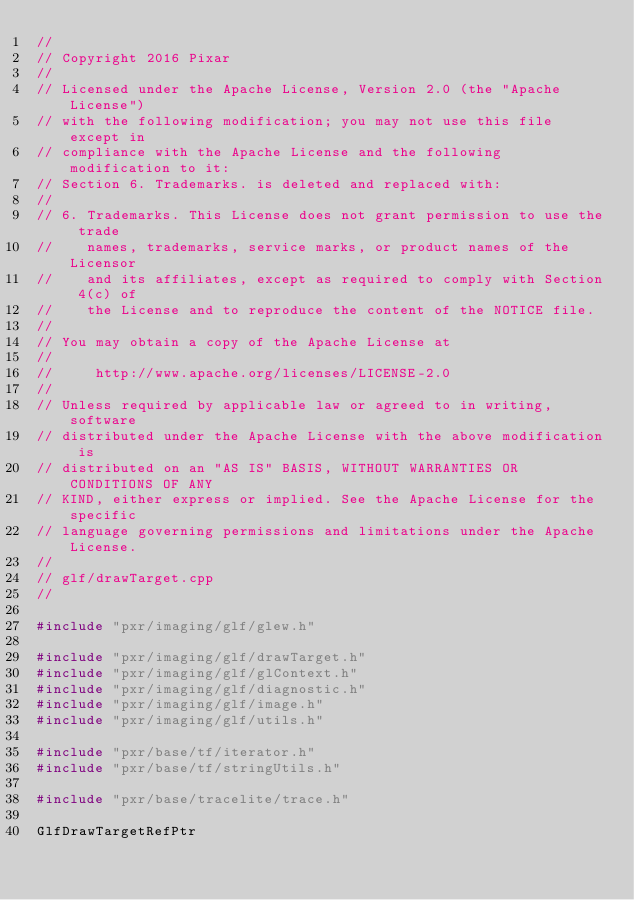Convert code to text. <code><loc_0><loc_0><loc_500><loc_500><_C++_>//
// Copyright 2016 Pixar
//
// Licensed under the Apache License, Version 2.0 (the "Apache License")
// with the following modification; you may not use this file except in
// compliance with the Apache License and the following modification to it:
// Section 6. Trademarks. is deleted and replaced with:
//
// 6. Trademarks. This License does not grant permission to use the trade
//    names, trademarks, service marks, or product names of the Licensor
//    and its affiliates, except as required to comply with Section 4(c) of
//    the License and to reproduce the content of the NOTICE file.
//
// You may obtain a copy of the Apache License at
//
//     http://www.apache.org/licenses/LICENSE-2.0
//
// Unless required by applicable law or agreed to in writing, software
// distributed under the Apache License with the above modification is
// distributed on an "AS IS" BASIS, WITHOUT WARRANTIES OR CONDITIONS OF ANY
// KIND, either express or implied. See the Apache License for the specific
// language governing permissions and limitations under the Apache License.
//
// glf/drawTarget.cpp
//

#include "pxr/imaging/glf/glew.h"

#include "pxr/imaging/glf/drawTarget.h"
#include "pxr/imaging/glf/glContext.h"
#include "pxr/imaging/glf/diagnostic.h"
#include "pxr/imaging/glf/image.h"
#include "pxr/imaging/glf/utils.h"

#include "pxr/base/tf/iterator.h"
#include "pxr/base/tf/stringUtils.h"

#include "pxr/base/tracelite/trace.h"

GlfDrawTargetRefPtr</code> 